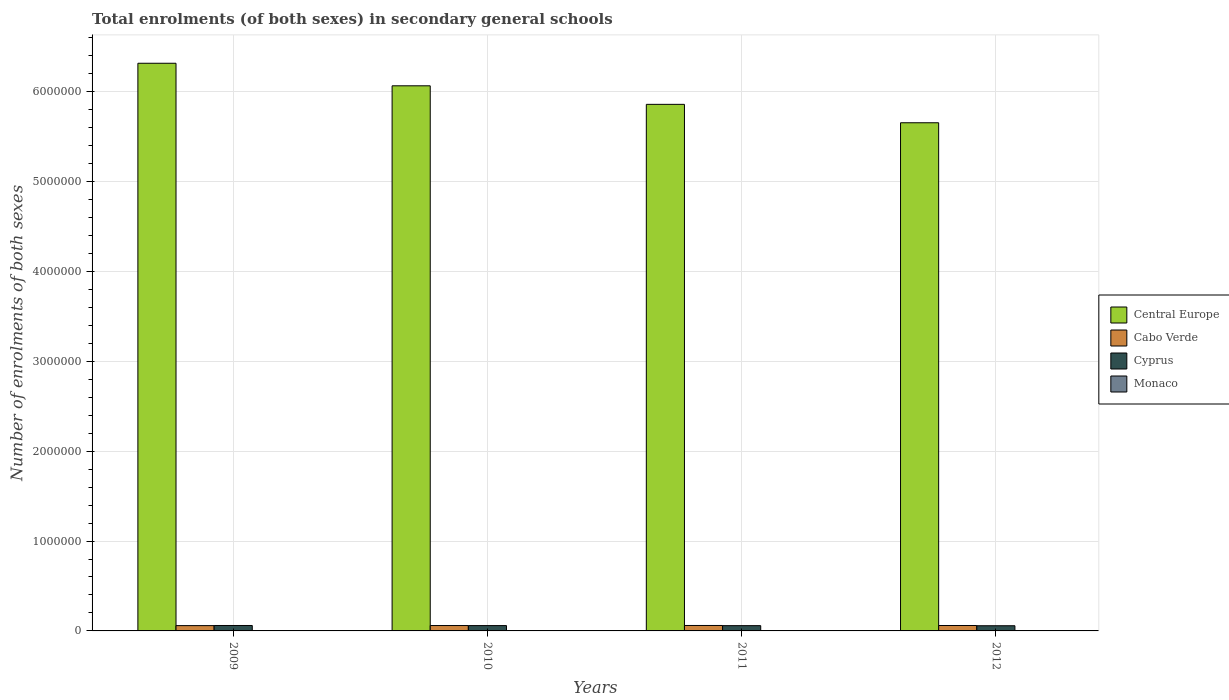Are the number of bars on each tick of the X-axis equal?
Your answer should be compact. Yes. How many bars are there on the 3rd tick from the left?
Provide a short and direct response. 4. What is the number of enrolments in secondary schools in Monaco in 2012?
Your answer should be very brief. 2657. Across all years, what is the maximum number of enrolments in secondary schools in Cyprus?
Give a very brief answer. 6.05e+04. Across all years, what is the minimum number of enrolments in secondary schools in Cabo Verde?
Give a very brief answer. 5.91e+04. In which year was the number of enrolments in secondary schools in Cabo Verde maximum?
Keep it short and to the point. 2011. In which year was the number of enrolments in secondary schools in Central Europe minimum?
Your answer should be very brief. 2012. What is the total number of enrolments in secondary schools in Central Europe in the graph?
Provide a short and direct response. 2.39e+07. What is the difference between the number of enrolments in secondary schools in Central Europe in 2010 and that in 2011?
Keep it short and to the point. 2.06e+05. What is the difference between the number of enrolments in secondary schools in Monaco in 2010 and the number of enrolments in secondary schools in Cyprus in 2012?
Offer a very short reply. -5.52e+04. What is the average number of enrolments in secondary schools in Monaco per year?
Keep it short and to the point. 2541.25. In the year 2010, what is the difference between the number of enrolments in secondary schools in Cyprus and number of enrolments in secondary schools in Cabo Verde?
Offer a terse response. -490. In how many years, is the number of enrolments in secondary schools in Cyprus greater than 1000000?
Your response must be concise. 0. What is the ratio of the number of enrolments in secondary schools in Cabo Verde in 2009 to that in 2012?
Offer a terse response. 0.98. What is the difference between the highest and the second highest number of enrolments in secondary schools in Cyprus?
Your answer should be compact. 1025. What is the difference between the highest and the lowest number of enrolments in secondary schools in Cyprus?
Provide a succinct answer. 2819. Is the sum of the number of enrolments in secondary schools in Cyprus in 2010 and 2012 greater than the maximum number of enrolments in secondary schools in Monaco across all years?
Make the answer very short. Yes. Is it the case that in every year, the sum of the number of enrolments in secondary schools in Cyprus and number of enrolments in secondary schools in Monaco is greater than the sum of number of enrolments in secondary schools in Central Europe and number of enrolments in secondary schools in Cabo Verde?
Ensure brevity in your answer.  No. What does the 3rd bar from the left in 2010 represents?
Give a very brief answer. Cyprus. What does the 1st bar from the right in 2010 represents?
Your answer should be very brief. Monaco. Is it the case that in every year, the sum of the number of enrolments in secondary schools in Central Europe and number of enrolments in secondary schools in Cyprus is greater than the number of enrolments in secondary schools in Cabo Verde?
Provide a succinct answer. Yes. What is the difference between two consecutive major ticks on the Y-axis?
Offer a terse response. 1.00e+06. Are the values on the major ticks of Y-axis written in scientific E-notation?
Offer a terse response. No. Does the graph contain any zero values?
Your answer should be very brief. No. How are the legend labels stacked?
Offer a very short reply. Vertical. What is the title of the graph?
Offer a terse response. Total enrolments (of both sexes) in secondary general schools. What is the label or title of the X-axis?
Offer a very short reply. Years. What is the label or title of the Y-axis?
Offer a very short reply. Number of enrolments of both sexes. What is the Number of enrolments of both sexes in Central Europe in 2009?
Offer a very short reply. 6.32e+06. What is the Number of enrolments of both sexes of Cabo Verde in 2009?
Provide a succinct answer. 5.91e+04. What is the Number of enrolments of both sexes of Cyprus in 2009?
Give a very brief answer. 6.05e+04. What is the Number of enrolments of both sexes of Monaco in 2009?
Your answer should be very brief. 2440. What is the Number of enrolments of both sexes in Central Europe in 2010?
Offer a terse response. 6.07e+06. What is the Number of enrolments of both sexes in Cabo Verde in 2010?
Make the answer very short. 5.99e+04. What is the Number of enrolments of both sexes of Cyprus in 2010?
Offer a terse response. 5.94e+04. What is the Number of enrolments of both sexes of Monaco in 2010?
Ensure brevity in your answer.  2458. What is the Number of enrolments of both sexes in Central Europe in 2011?
Your response must be concise. 5.86e+06. What is the Number of enrolments of both sexes in Cabo Verde in 2011?
Your response must be concise. 6.05e+04. What is the Number of enrolments of both sexes in Cyprus in 2011?
Provide a short and direct response. 5.87e+04. What is the Number of enrolments of both sexes in Monaco in 2011?
Provide a short and direct response. 2610. What is the Number of enrolments of both sexes of Central Europe in 2012?
Ensure brevity in your answer.  5.65e+06. What is the Number of enrolments of both sexes of Cabo Verde in 2012?
Provide a short and direct response. 6.03e+04. What is the Number of enrolments of both sexes in Cyprus in 2012?
Your answer should be very brief. 5.76e+04. What is the Number of enrolments of both sexes in Monaco in 2012?
Offer a very short reply. 2657. Across all years, what is the maximum Number of enrolments of both sexes of Central Europe?
Keep it short and to the point. 6.32e+06. Across all years, what is the maximum Number of enrolments of both sexes of Cabo Verde?
Ensure brevity in your answer.  6.05e+04. Across all years, what is the maximum Number of enrolments of both sexes of Cyprus?
Your response must be concise. 6.05e+04. Across all years, what is the maximum Number of enrolments of both sexes in Monaco?
Make the answer very short. 2657. Across all years, what is the minimum Number of enrolments of both sexes in Central Europe?
Give a very brief answer. 5.65e+06. Across all years, what is the minimum Number of enrolments of both sexes in Cabo Verde?
Provide a succinct answer. 5.91e+04. Across all years, what is the minimum Number of enrolments of both sexes of Cyprus?
Your response must be concise. 5.76e+04. Across all years, what is the minimum Number of enrolments of both sexes in Monaco?
Your response must be concise. 2440. What is the total Number of enrolments of both sexes of Central Europe in the graph?
Your response must be concise. 2.39e+07. What is the total Number of enrolments of both sexes of Cabo Verde in the graph?
Your response must be concise. 2.40e+05. What is the total Number of enrolments of both sexes of Cyprus in the graph?
Keep it short and to the point. 2.36e+05. What is the total Number of enrolments of both sexes of Monaco in the graph?
Offer a very short reply. 1.02e+04. What is the difference between the Number of enrolments of both sexes of Central Europe in 2009 and that in 2010?
Make the answer very short. 2.51e+05. What is the difference between the Number of enrolments of both sexes in Cabo Verde in 2009 and that in 2010?
Your answer should be compact. -835. What is the difference between the Number of enrolments of both sexes in Cyprus in 2009 and that in 2010?
Your response must be concise. 1025. What is the difference between the Number of enrolments of both sexes of Monaco in 2009 and that in 2010?
Provide a succinct answer. -18. What is the difference between the Number of enrolments of both sexes in Central Europe in 2009 and that in 2011?
Provide a succinct answer. 4.57e+05. What is the difference between the Number of enrolments of both sexes of Cabo Verde in 2009 and that in 2011?
Your answer should be compact. -1431. What is the difference between the Number of enrolments of both sexes of Cyprus in 2009 and that in 2011?
Keep it short and to the point. 1735. What is the difference between the Number of enrolments of both sexes of Monaco in 2009 and that in 2011?
Make the answer very short. -170. What is the difference between the Number of enrolments of both sexes in Central Europe in 2009 and that in 2012?
Offer a terse response. 6.62e+05. What is the difference between the Number of enrolments of both sexes in Cabo Verde in 2009 and that in 2012?
Offer a very short reply. -1211. What is the difference between the Number of enrolments of both sexes of Cyprus in 2009 and that in 2012?
Keep it short and to the point. 2819. What is the difference between the Number of enrolments of both sexes of Monaco in 2009 and that in 2012?
Your answer should be very brief. -217. What is the difference between the Number of enrolments of both sexes in Central Europe in 2010 and that in 2011?
Provide a succinct answer. 2.06e+05. What is the difference between the Number of enrolments of both sexes in Cabo Verde in 2010 and that in 2011?
Your response must be concise. -596. What is the difference between the Number of enrolments of both sexes in Cyprus in 2010 and that in 2011?
Provide a succinct answer. 710. What is the difference between the Number of enrolments of both sexes in Monaco in 2010 and that in 2011?
Offer a very short reply. -152. What is the difference between the Number of enrolments of both sexes in Central Europe in 2010 and that in 2012?
Ensure brevity in your answer.  4.11e+05. What is the difference between the Number of enrolments of both sexes in Cabo Verde in 2010 and that in 2012?
Keep it short and to the point. -376. What is the difference between the Number of enrolments of both sexes in Cyprus in 2010 and that in 2012?
Offer a very short reply. 1794. What is the difference between the Number of enrolments of both sexes in Monaco in 2010 and that in 2012?
Your answer should be compact. -199. What is the difference between the Number of enrolments of both sexes in Central Europe in 2011 and that in 2012?
Provide a succinct answer. 2.05e+05. What is the difference between the Number of enrolments of both sexes in Cabo Verde in 2011 and that in 2012?
Keep it short and to the point. 220. What is the difference between the Number of enrolments of both sexes in Cyprus in 2011 and that in 2012?
Keep it short and to the point. 1084. What is the difference between the Number of enrolments of both sexes of Monaco in 2011 and that in 2012?
Offer a very short reply. -47. What is the difference between the Number of enrolments of both sexes in Central Europe in 2009 and the Number of enrolments of both sexes in Cabo Verde in 2010?
Your answer should be very brief. 6.26e+06. What is the difference between the Number of enrolments of both sexes of Central Europe in 2009 and the Number of enrolments of both sexes of Cyprus in 2010?
Your answer should be compact. 6.26e+06. What is the difference between the Number of enrolments of both sexes in Central Europe in 2009 and the Number of enrolments of both sexes in Monaco in 2010?
Ensure brevity in your answer.  6.31e+06. What is the difference between the Number of enrolments of both sexes in Cabo Verde in 2009 and the Number of enrolments of both sexes in Cyprus in 2010?
Keep it short and to the point. -345. What is the difference between the Number of enrolments of both sexes of Cabo Verde in 2009 and the Number of enrolments of both sexes of Monaco in 2010?
Keep it short and to the point. 5.66e+04. What is the difference between the Number of enrolments of both sexes of Cyprus in 2009 and the Number of enrolments of both sexes of Monaco in 2010?
Give a very brief answer. 5.80e+04. What is the difference between the Number of enrolments of both sexes in Central Europe in 2009 and the Number of enrolments of both sexes in Cabo Verde in 2011?
Give a very brief answer. 6.26e+06. What is the difference between the Number of enrolments of both sexes in Central Europe in 2009 and the Number of enrolments of both sexes in Cyprus in 2011?
Provide a short and direct response. 6.26e+06. What is the difference between the Number of enrolments of both sexes of Central Europe in 2009 and the Number of enrolments of both sexes of Monaco in 2011?
Offer a terse response. 6.31e+06. What is the difference between the Number of enrolments of both sexes in Cabo Verde in 2009 and the Number of enrolments of both sexes in Cyprus in 2011?
Provide a succinct answer. 365. What is the difference between the Number of enrolments of both sexes of Cabo Verde in 2009 and the Number of enrolments of both sexes of Monaco in 2011?
Your response must be concise. 5.65e+04. What is the difference between the Number of enrolments of both sexes of Cyprus in 2009 and the Number of enrolments of both sexes of Monaco in 2011?
Offer a very short reply. 5.78e+04. What is the difference between the Number of enrolments of both sexes of Central Europe in 2009 and the Number of enrolments of both sexes of Cabo Verde in 2012?
Offer a terse response. 6.26e+06. What is the difference between the Number of enrolments of both sexes of Central Europe in 2009 and the Number of enrolments of both sexes of Cyprus in 2012?
Make the answer very short. 6.26e+06. What is the difference between the Number of enrolments of both sexes of Central Europe in 2009 and the Number of enrolments of both sexes of Monaco in 2012?
Give a very brief answer. 6.31e+06. What is the difference between the Number of enrolments of both sexes in Cabo Verde in 2009 and the Number of enrolments of both sexes in Cyprus in 2012?
Ensure brevity in your answer.  1449. What is the difference between the Number of enrolments of both sexes of Cabo Verde in 2009 and the Number of enrolments of both sexes of Monaco in 2012?
Offer a terse response. 5.64e+04. What is the difference between the Number of enrolments of both sexes in Cyprus in 2009 and the Number of enrolments of both sexes in Monaco in 2012?
Provide a short and direct response. 5.78e+04. What is the difference between the Number of enrolments of both sexes in Central Europe in 2010 and the Number of enrolments of both sexes in Cabo Verde in 2011?
Ensure brevity in your answer.  6.00e+06. What is the difference between the Number of enrolments of both sexes in Central Europe in 2010 and the Number of enrolments of both sexes in Cyprus in 2011?
Your answer should be compact. 6.01e+06. What is the difference between the Number of enrolments of both sexes of Central Europe in 2010 and the Number of enrolments of both sexes of Monaco in 2011?
Offer a terse response. 6.06e+06. What is the difference between the Number of enrolments of both sexes of Cabo Verde in 2010 and the Number of enrolments of both sexes of Cyprus in 2011?
Ensure brevity in your answer.  1200. What is the difference between the Number of enrolments of both sexes in Cabo Verde in 2010 and the Number of enrolments of both sexes in Monaco in 2011?
Ensure brevity in your answer.  5.73e+04. What is the difference between the Number of enrolments of both sexes of Cyprus in 2010 and the Number of enrolments of both sexes of Monaco in 2011?
Keep it short and to the point. 5.68e+04. What is the difference between the Number of enrolments of both sexes in Central Europe in 2010 and the Number of enrolments of both sexes in Cabo Verde in 2012?
Your answer should be very brief. 6.00e+06. What is the difference between the Number of enrolments of both sexes in Central Europe in 2010 and the Number of enrolments of both sexes in Cyprus in 2012?
Your answer should be very brief. 6.01e+06. What is the difference between the Number of enrolments of both sexes of Central Europe in 2010 and the Number of enrolments of both sexes of Monaco in 2012?
Provide a succinct answer. 6.06e+06. What is the difference between the Number of enrolments of both sexes in Cabo Verde in 2010 and the Number of enrolments of both sexes in Cyprus in 2012?
Your answer should be compact. 2284. What is the difference between the Number of enrolments of both sexes in Cabo Verde in 2010 and the Number of enrolments of both sexes in Monaco in 2012?
Give a very brief answer. 5.73e+04. What is the difference between the Number of enrolments of both sexes in Cyprus in 2010 and the Number of enrolments of both sexes in Monaco in 2012?
Offer a terse response. 5.68e+04. What is the difference between the Number of enrolments of both sexes in Central Europe in 2011 and the Number of enrolments of both sexes in Cabo Verde in 2012?
Your response must be concise. 5.80e+06. What is the difference between the Number of enrolments of both sexes in Central Europe in 2011 and the Number of enrolments of both sexes in Cyprus in 2012?
Ensure brevity in your answer.  5.80e+06. What is the difference between the Number of enrolments of both sexes of Central Europe in 2011 and the Number of enrolments of both sexes of Monaco in 2012?
Provide a succinct answer. 5.86e+06. What is the difference between the Number of enrolments of both sexes of Cabo Verde in 2011 and the Number of enrolments of both sexes of Cyprus in 2012?
Offer a terse response. 2880. What is the difference between the Number of enrolments of both sexes of Cabo Verde in 2011 and the Number of enrolments of both sexes of Monaco in 2012?
Keep it short and to the point. 5.79e+04. What is the difference between the Number of enrolments of both sexes in Cyprus in 2011 and the Number of enrolments of both sexes in Monaco in 2012?
Ensure brevity in your answer.  5.61e+04. What is the average Number of enrolments of both sexes in Central Europe per year?
Ensure brevity in your answer.  5.97e+06. What is the average Number of enrolments of both sexes of Cabo Verde per year?
Keep it short and to the point. 6.00e+04. What is the average Number of enrolments of both sexes in Cyprus per year?
Offer a terse response. 5.91e+04. What is the average Number of enrolments of both sexes of Monaco per year?
Offer a terse response. 2541.25. In the year 2009, what is the difference between the Number of enrolments of both sexes of Central Europe and Number of enrolments of both sexes of Cabo Verde?
Ensure brevity in your answer.  6.26e+06. In the year 2009, what is the difference between the Number of enrolments of both sexes of Central Europe and Number of enrolments of both sexes of Cyprus?
Offer a very short reply. 6.26e+06. In the year 2009, what is the difference between the Number of enrolments of both sexes in Central Europe and Number of enrolments of both sexes in Monaco?
Offer a terse response. 6.31e+06. In the year 2009, what is the difference between the Number of enrolments of both sexes in Cabo Verde and Number of enrolments of both sexes in Cyprus?
Give a very brief answer. -1370. In the year 2009, what is the difference between the Number of enrolments of both sexes in Cabo Verde and Number of enrolments of both sexes in Monaco?
Provide a short and direct response. 5.66e+04. In the year 2009, what is the difference between the Number of enrolments of both sexes of Cyprus and Number of enrolments of both sexes of Monaco?
Your response must be concise. 5.80e+04. In the year 2010, what is the difference between the Number of enrolments of both sexes in Central Europe and Number of enrolments of both sexes in Cabo Verde?
Offer a very short reply. 6.01e+06. In the year 2010, what is the difference between the Number of enrolments of both sexes in Central Europe and Number of enrolments of both sexes in Cyprus?
Provide a short and direct response. 6.01e+06. In the year 2010, what is the difference between the Number of enrolments of both sexes of Central Europe and Number of enrolments of both sexes of Monaco?
Your answer should be compact. 6.06e+06. In the year 2010, what is the difference between the Number of enrolments of both sexes of Cabo Verde and Number of enrolments of both sexes of Cyprus?
Provide a short and direct response. 490. In the year 2010, what is the difference between the Number of enrolments of both sexes of Cabo Verde and Number of enrolments of both sexes of Monaco?
Your response must be concise. 5.75e+04. In the year 2010, what is the difference between the Number of enrolments of both sexes of Cyprus and Number of enrolments of both sexes of Monaco?
Your answer should be compact. 5.70e+04. In the year 2011, what is the difference between the Number of enrolments of both sexes in Central Europe and Number of enrolments of both sexes in Cabo Verde?
Your answer should be very brief. 5.80e+06. In the year 2011, what is the difference between the Number of enrolments of both sexes of Central Europe and Number of enrolments of both sexes of Cyprus?
Give a very brief answer. 5.80e+06. In the year 2011, what is the difference between the Number of enrolments of both sexes in Central Europe and Number of enrolments of both sexes in Monaco?
Offer a very short reply. 5.86e+06. In the year 2011, what is the difference between the Number of enrolments of both sexes in Cabo Verde and Number of enrolments of both sexes in Cyprus?
Your answer should be compact. 1796. In the year 2011, what is the difference between the Number of enrolments of both sexes of Cabo Verde and Number of enrolments of both sexes of Monaco?
Keep it short and to the point. 5.79e+04. In the year 2011, what is the difference between the Number of enrolments of both sexes of Cyprus and Number of enrolments of both sexes of Monaco?
Provide a short and direct response. 5.61e+04. In the year 2012, what is the difference between the Number of enrolments of both sexes in Central Europe and Number of enrolments of both sexes in Cabo Verde?
Ensure brevity in your answer.  5.59e+06. In the year 2012, what is the difference between the Number of enrolments of both sexes in Central Europe and Number of enrolments of both sexes in Cyprus?
Provide a succinct answer. 5.60e+06. In the year 2012, what is the difference between the Number of enrolments of both sexes in Central Europe and Number of enrolments of both sexes in Monaco?
Provide a succinct answer. 5.65e+06. In the year 2012, what is the difference between the Number of enrolments of both sexes of Cabo Verde and Number of enrolments of both sexes of Cyprus?
Provide a short and direct response. 2660. In the year 2012, what is the difference between the Number of enrolments of both sexes of Cabo Verde and Number of enrolments of both sexes of Monaco?
Offer a terse response. 5.76e+04. In the year 2012, what is the difference between the Number of enrolments of both sexes of Cyprus and Number of enrolments of both sexes of Monaco?
Your answer should be very brief. 5.50e+04. What is the ratio of the Number of enrolments of both sexes of Central Europe in 2009 to that in 2010?
Give a very brief answer. 1.04. What is the ratio of the Number of enrolments of both sexes in Cabo Verde in 2009 to that in 2010?
Your response must be concise. 0.99. What is the ratio of the Number of enrolments of both sexes in Cyprus in 2009 to that in 2010?
Give a very brief answer. 1.02. What is the ratio of the Number of enrolments of both sexes in Monaco in 2009 to that in 2010?
Keep it short and to the point. 0.99. What is the ratio of the Number of enrolments of both sexes of Central Europe in 2009 to that in 2011?
Your answer should be very brief. 1.08. What is the ratio of the Number of enrolments of both sexes in Cabo Verde in 2009 to that in 2011?
Make the answer very short. 0.98. What is the ratio of the Number of enrolments of both sexes of Cyprus in 2009 to that in 2011?
Offer a very short reply. 1.03. What is the ratio of the Number of enrolments of both sexes in Monaco in 2009 to that in 2011?
Make the answer very short. 0.93. What is the ratio of the Number of enrolments of both sexes in Central Europe in 2009 to that in 2012?
Offer a very short reply. 1.12. What is the ratio of the Number of enrolments of both sexes of Cabo Verde in 2009 to that in 2012?
Your answer should be compact. 0.98. What is the ratio of the Number of enrolments of both sexes in Cyprus in 2009 to that in 2012?
Ensure brevity in your answer.  1.05. What is the ratio of the Number of enrolments of both sexes of Monaco in 2009 to that in 2012?
Your answer should be very brief. 0.92. What is the ratio of the Number of enrolments of both sexes of Central Europe in 2010 to that in 2011?
Provide a short and direct response. 1.04. What is the ratio of the Number of enrolments of both sexes of Cabo Verde in 2010 to that in 2011?
Your response must be concise. 0.99. What is the ratio of the Number of enrolments of both sexes of Cyprus in 2010 to that in 2011?
Provide a succinct answer. 1.01. What is the ratio of the Number of enrolments of both sexes of Monaco in 2010 to that in 2011?
Provide a short and direct response. 0.94. What is the ratio of the Number of enrolments of both sexes in Central Europe in 2010 to that in 2012?
Offer a very short reply. 1.07. What is the ratio of the Number of enrolments of both sexes of Cyprus in 2010 to that in 2012?
Provide a short and direct response. 1.03. What is the ratio of the Number of enrolments of both sexes of Monaco in 2010 to that in 2012?
Provide a succinct answer. 0.93. What is the ratio of the Number of enrolments of both sexes of Central Europe in 2011 to that in 2012?
Your answer should be compact. 1.04. What is the ratio of the Number of enrolments of both sexes of Cyprus in 2011 to that in 2012?
Provide a succinct answer. 1.02. What is the ratio of the Number of enrolments of both sexes of Monaco in 2011 to that in 2012?
Your response must be concise. 0.98. What is the difference between the highest and the second highest Number of enrolments of both sexes in Central Europe?
Make the answer very short. 2.51e+05. What is the difference between the highest and the second highest Number of enrolments of both sexes of Cabo Verde?
Provide a succinct answer. 220. What is the difference between the highest and the second highest Number of enrolments of both sexes in Cyprus?
Keep it short and to the point. 1025. What is the difference between the highest and the second highest Number of enrolments of both sexes in Monaco?
Ensure brevity in your answer.  47. What is the difference between the highest and the lowest Number of enrolments of both sexes of Central Europe?
Your response must be concise. 6.62e+05. What is the difference between the highest and the lowest Number of enrolments of both sexes in Cabo Verde?
Ensure brevity in your answer.  1431. What is the difference between the highest and the lowest Number of enrolments of both sexes of Cyprus?
Keep it short and to the point. 2819. What is the difference between the highest and the lowest Number of enrolments of both sexes in Monaco?
Your answer should be compact. 217. 